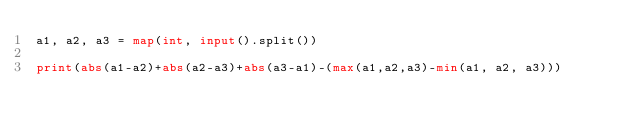Convert code to text. <code><loc_0><loc_0><loc_500><loc_500><_Python_>a1, a2, a3 = map(int, input().split())

print(abs(a1-a2)+abs(a2-a3)+abs(a3-a1)-(max(a1,a2,a3)-min(a1, a2, a3)))</code> 